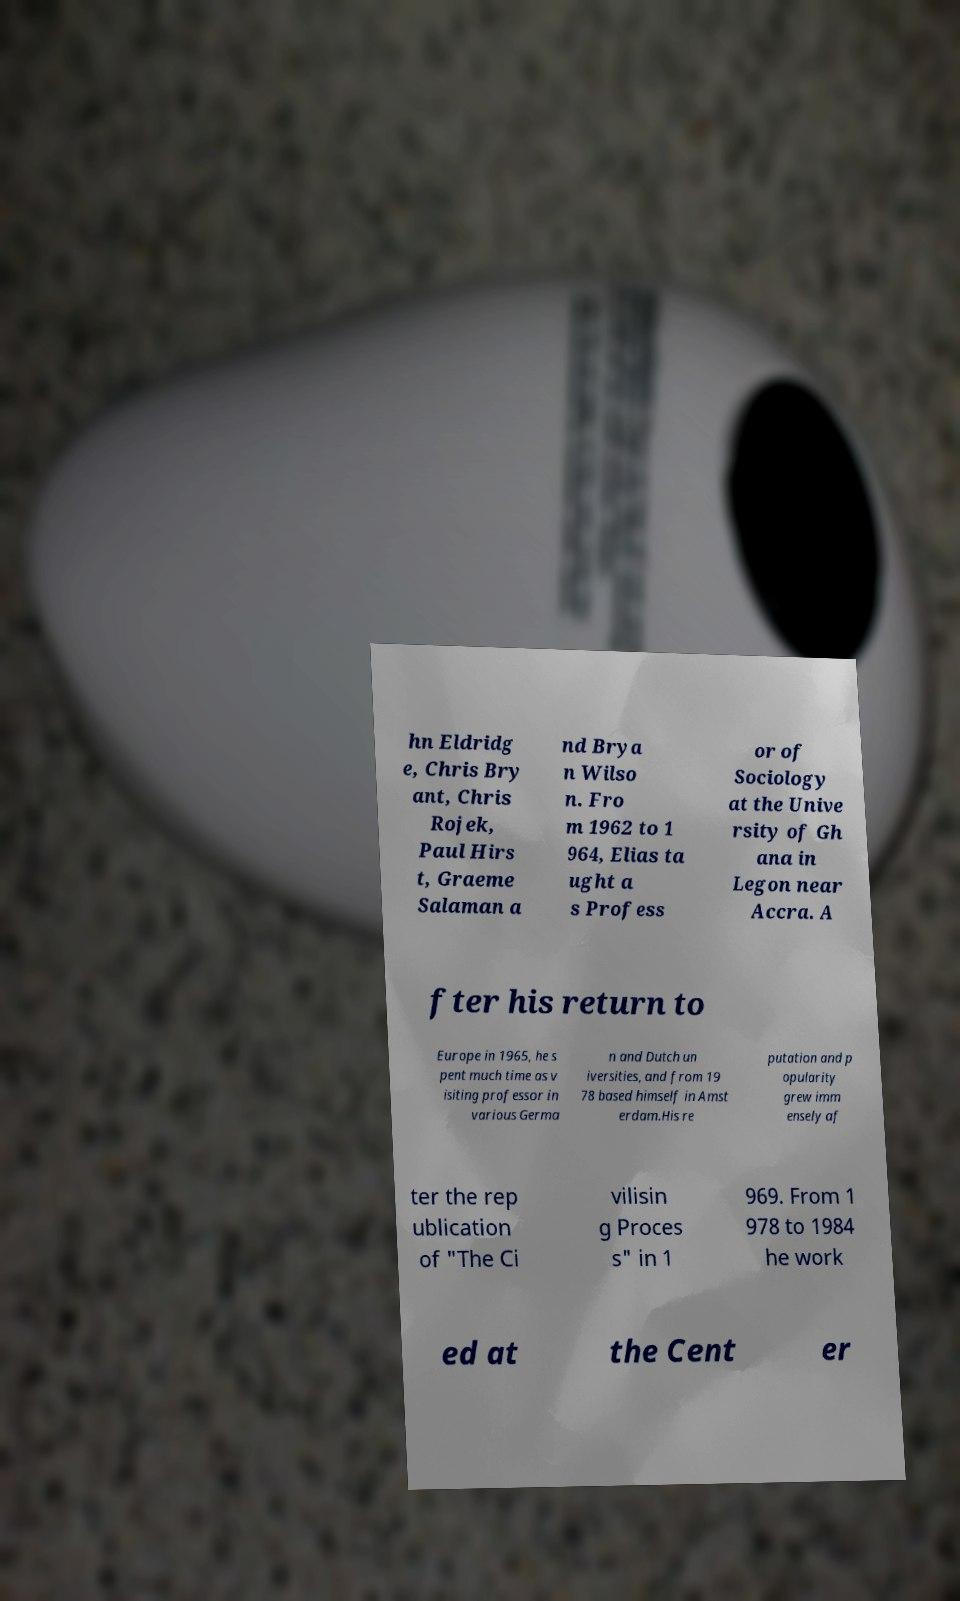Please read and relay the text visible in this image. What does it say? hn Eldridg e, Chris Bry ant, Chris Rojek, Paul Hirs t, Graeme Salaman a nd Brya n Wilso n. Fro m 1962 to 1 964, Elias ta ught a s Profess or of Sociology at the Unive rsity of Gh ana in Legon near Accra. A fter his return to Europe in 1965, he s pent much time as v isiting professor in various Germa n and Dutch un iversities, and from 19 78 based himself in Amst erdam.His re putation and p opularity grew imm ensely af ter the rep ublication of "The Ci vilisin g Proces s" in 1 969. From 1 978 to 1984 he work ed at the Cent er 